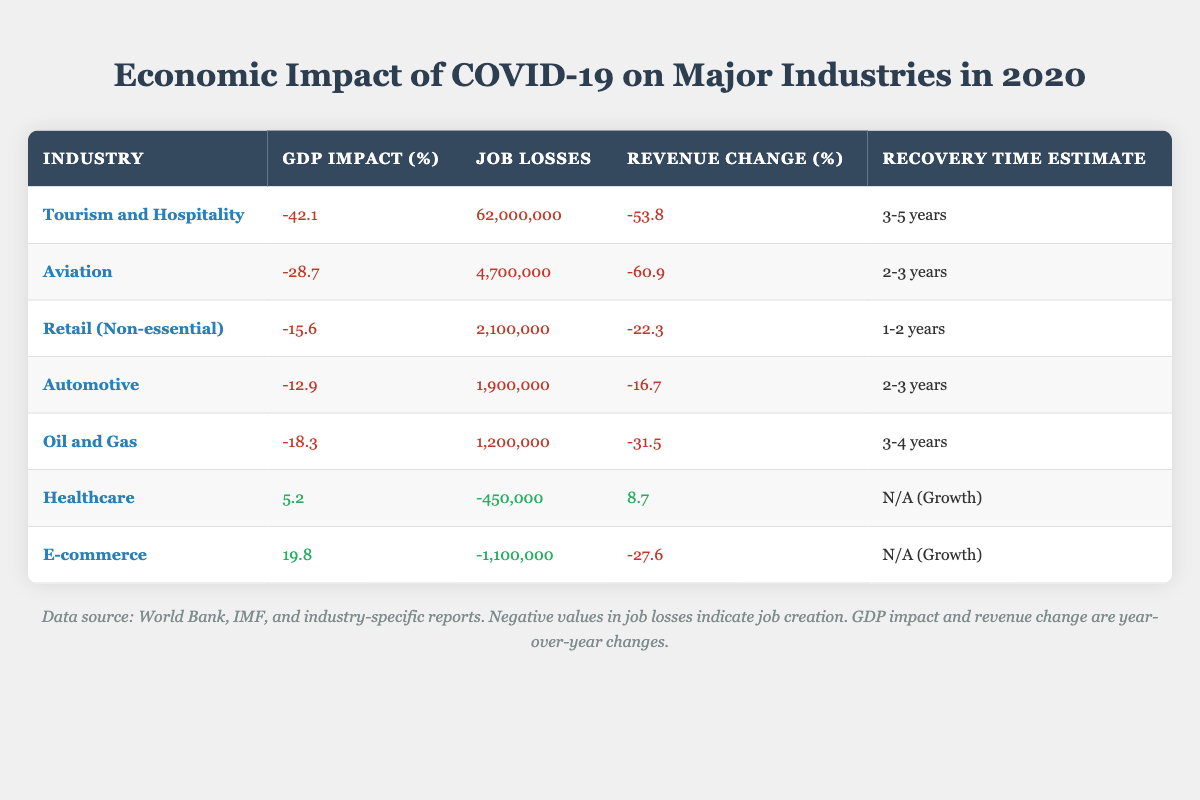What is the GDP impact of the Tourism and Hospitality industry? The GDP impact for the Tourism and Hospitality industry is listed directly in the table as -42.1%.
Answer: -42.1% How many job losses are reported in the Aviation industry? The number of job losses in the Aviation industry is directly provided in the table, which states there were 4,700,000 job losses.
Answer: 4,700,000 Which industry has the longest recovery time estimate? By comparing the recovery time estimates for each industry in the table, Tourism and Hospitality has the longest recovery time at 3-5 years.
Answer: 3-5 years What is the average revenue decline for the industries with a negative impact? We first identify the industries with negative revenue change: Tourism and Hospitality (-53.8%), Aviation (-60.9%), Retail (-22.3%), Automotive (-16.7%), and Oil and Gas (-31.5%). Adding these values gives us a total of -185.2%. There are 5 industries, so the average is -185.2% / 5 = -37.04%.
Answer: -37.04% Is the Healthcare industry experiencing job losses or job creation according to the data? The table indicates that the Healthcare industry has -450,000 job losses, which actually refers to job creation, as negative values indicate the opposite.
Answer: Job creation Which industry experienced the highest revenue decline percentage? The table shows that the Aviation industry experienced the highest revenue decline percentage at -60.9%.
Answer: -60.9% How does the GDP impact of E-commerce compare to that of Automotive? The GDP impact for E-commerce is 19.8%, while for Automotive, it is -12.9%. Since 19.8% is positive and -12.9% is negative, E-commerce has a significantly higher GDP impact compared to Automotive.
Answer: E-commerce is higher What total number of jobs were lost across all negative impact industries? We will sum up the job losses from the negative impact industries: 62,000,000 (Tourism) + 4,700,000 (Aviation) + 2,100,000 (Retail) + 1,900,000 (Automotive) + 1,200,000 (Oil and Gas) = 72,900,000.
Answer: 72,900,000 